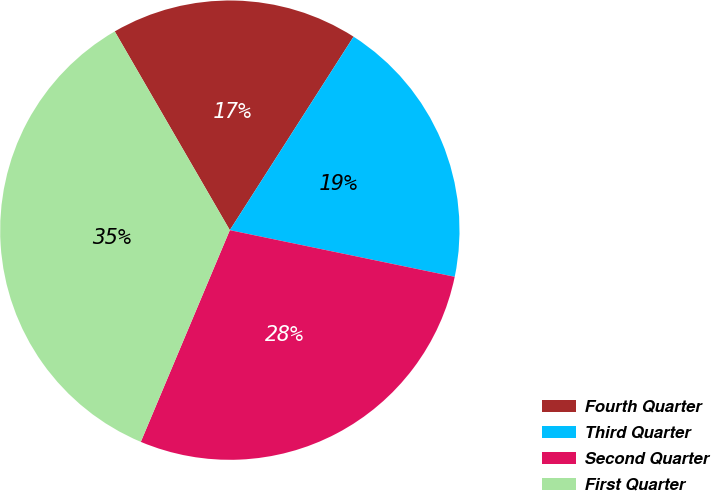Convert chart. <chart><loc_0><loc_0><loc_500><loc_500><pie_chart><fcel>Fourth Quarter<fcel>Third Quarter<fcel>Second Quarter<fcel>First Quarter<nl><fcel>17.41%<fcel>19.2%<fcel>28.08%<fcel>35.31%<nl></chart> 